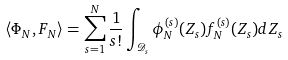<formula> <loc_0><loc_0><loc_500><loc_500>\left < \Phi _ { N } , F _ { N } \right > = \sum _ { s = 1 } ^ { N } \frac { 1 } { s ! } \int _ { \mathcal { D } _ { s } } \phi _ { N } ^ { ( s ) } ( Z _ { s } ) f _ { N } ^ { ( s ) } ( Z _ { s } ) d Z _ { s }</formula> 